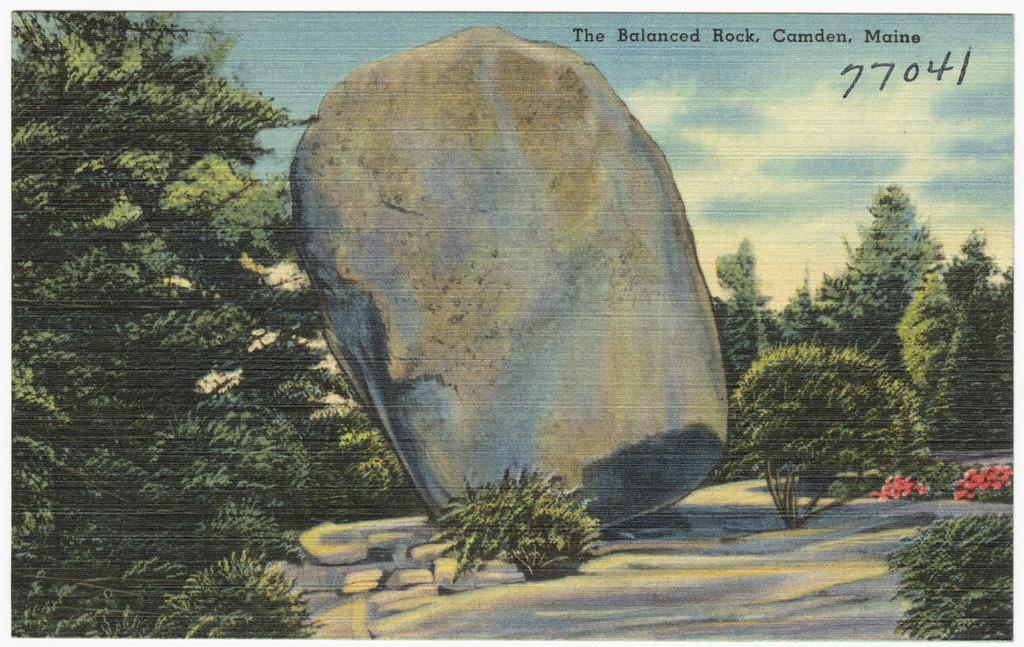<image>
Present a compact description of the photo's key features. a 77041 label that is in the sky 